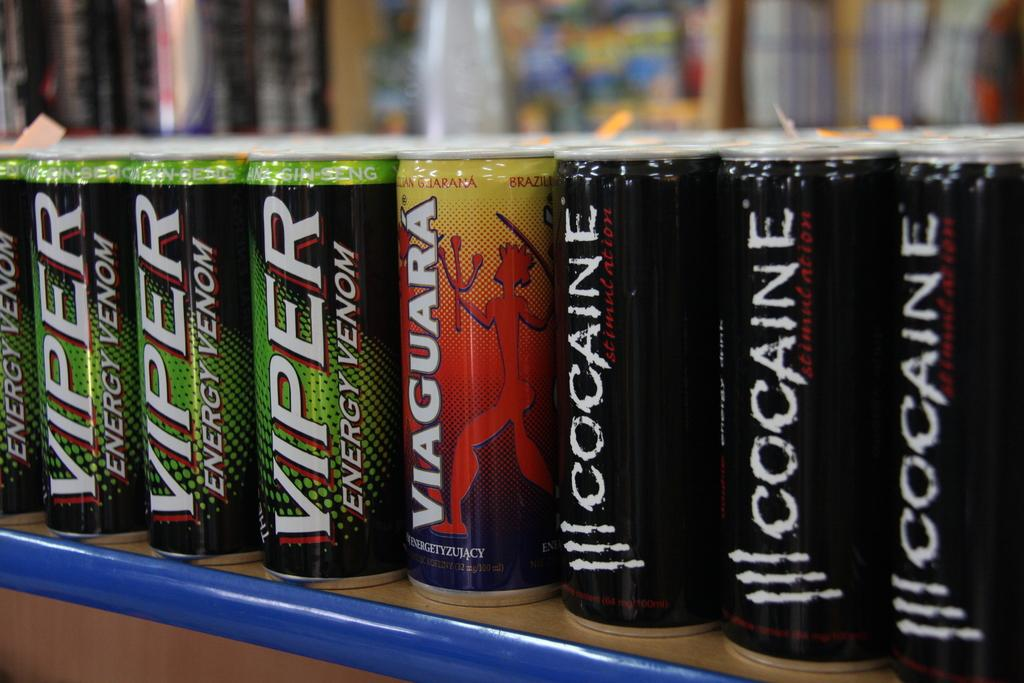<image>
Give a short and clear explanation of the subsequent image. The beverage in the green and black can is called Viper Energy Venom. 